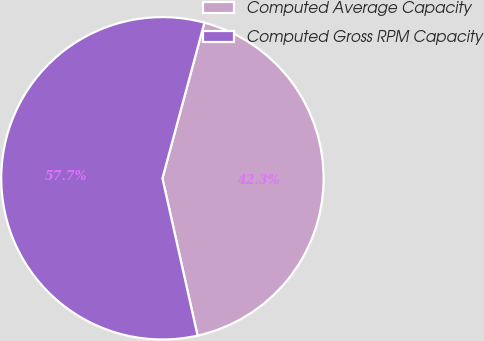<chart> <loc_0><loc_0><loc_500><loc_500><pie_chart><fcel>Computed Average Capacity<fcel>Computed Gross RPM Capacity<nl><fcel>42.31%<fcel>57.69%<nl></chart> 